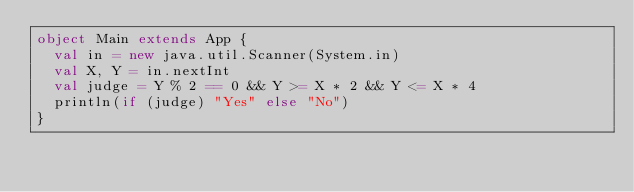<code> <loc_0><loc_0><loc_500><loc_500><_Scala_>object Main extends App {
  val in = new java.util.Scanner(System.in)
  val X, Y = in.nextInt
  val judge = Y % 2 == 0 && Y >= X * 2 && Y <= X * 4
  println(if (judge) "Yes" else "No")
}</code> 